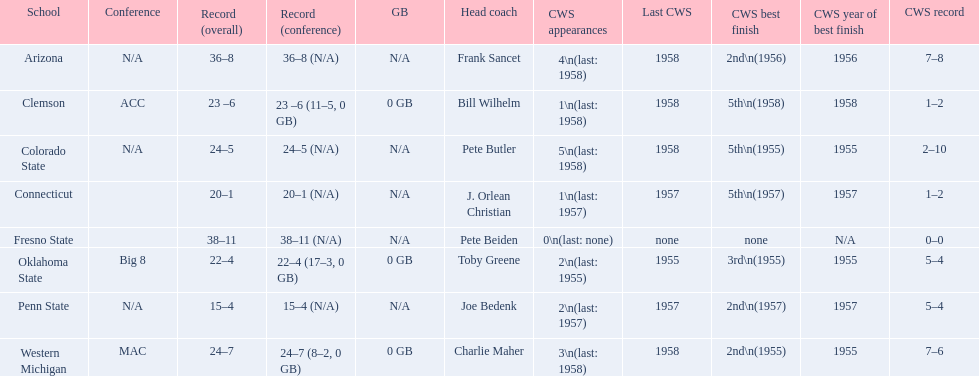What are the listed schools? Arizona, Clemson, Colorado State, Connecticut, Fresno State, Oklahoma State, Penn State, Western Michigan. Which are clemson and western michigan? Clemson, Western Michigan. What are their corresponding numbers of cws appearances? 1\n(last: 1958), 3\n(last: 1958). Which value is larger? 3\n(last: 1958). To which school does that value belong to? Western Michigan. Can you parse all the data within this table? {'header': ['School', 'Conference', 'Record (overall)', 'Record (conference)', 'GB', 'Head coach', 'CWS appearances', 'Last CWS', 'CWS best finish', 'CWS year of best finish', 'CWS record'], 'rows': [['Arizona', 'N/A', '36–8', '36–8 (N/A)', 'N/A', 'Frank Sancet', '4\\n(last: 1958)', '1958', '2nd\\n(1956)', '1956', '7–8'], ['Clemson', 'ACC', '23 –6', '23 –6 (11–5, 0 GB)', '0 GB', 'Bill Wilhelm', '1\\n(last: 1958)', '1958', '5th\\n(1958)', '1958', '1–2'], ['Colorado State', 'N/A', '24–5', '24–5 (N/A)', 'N/A', 'Pete Butler', '5\\n(last: 1958)', '1958', '5th\\n(1955)', '1955', '2–10'], ['Connecticut', '', '20–1', '20–1 (N/A)', 'N/A', 'J. Orlean Christian', '1\\n(last: 1957)', '1957', '5th\\n(1957)', '1957', '1–2'], ['Fresno State', '', '38–11', '38–11 (N/A)', 'N/A', 'Pete Beiden', '0\\n(last: none)', 'none', 'none', 'N/A', '0–0'], ['Oklahoma State', 'Big 8', '22–4', '22–4 (17–3, 0 GB)', '0 GB', 'Toby Greene', '2\\n(last: 1955)', '1955', '3rd\\n(1955)', '1955', '5–4'], ['Penn State', 'N/A', '15–4', '15–4 (N/A)', 'N/A', 'Joe Bedenk', '2\\n(last: 1957)', '1957', '2nd\\n(1957)', '1957', '5–4'], ['Western Michigan', 'MAC', '24–7', '24–7 (8–2, 0 GB)', '0 GB', 'Charlie Maher', '3\\n(last: 1958)', '1958', '2nd\\n(1955)', '1955', '7–6']]} 